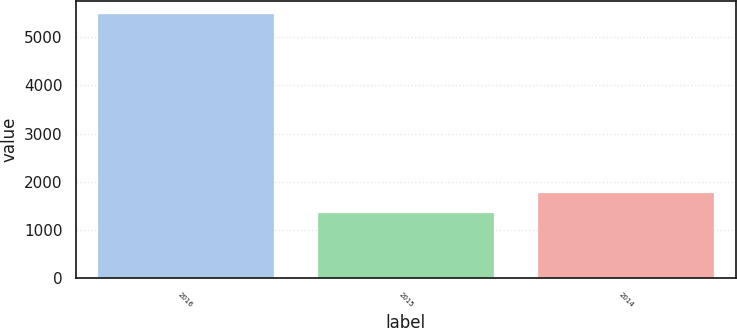Convert chart. <chart><loc_0><loc_0><loc_500><loc_500><bar_chart><fcel>2016<fcel>2015<fcel>2014<nl><fcel>5473<fcel>1363<fcel>1774<nl></chart> 